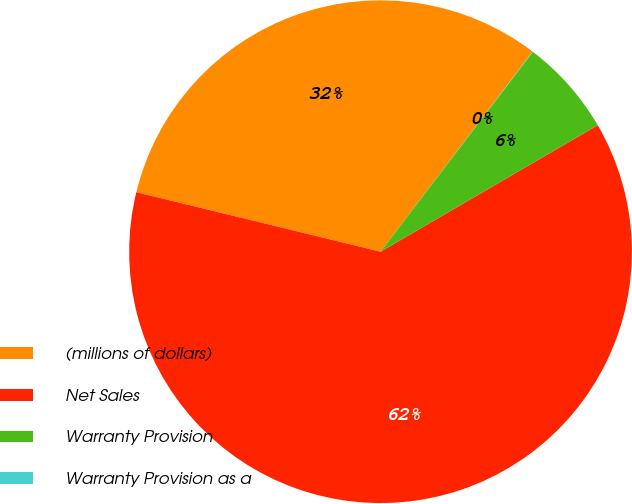Convert chart to OTSL. <chart><loc_0><loc_0><loc_500><loc_500><pie_chart><fcel>(millions of dollars)<fcel>Net Sales<fcel>Warranty Provision<fcel>Warranty Provision as a<nl><fcel>31.54%<fcel>62.2%<fcel>6.24%<fcel>0.02%<nl></chart> 